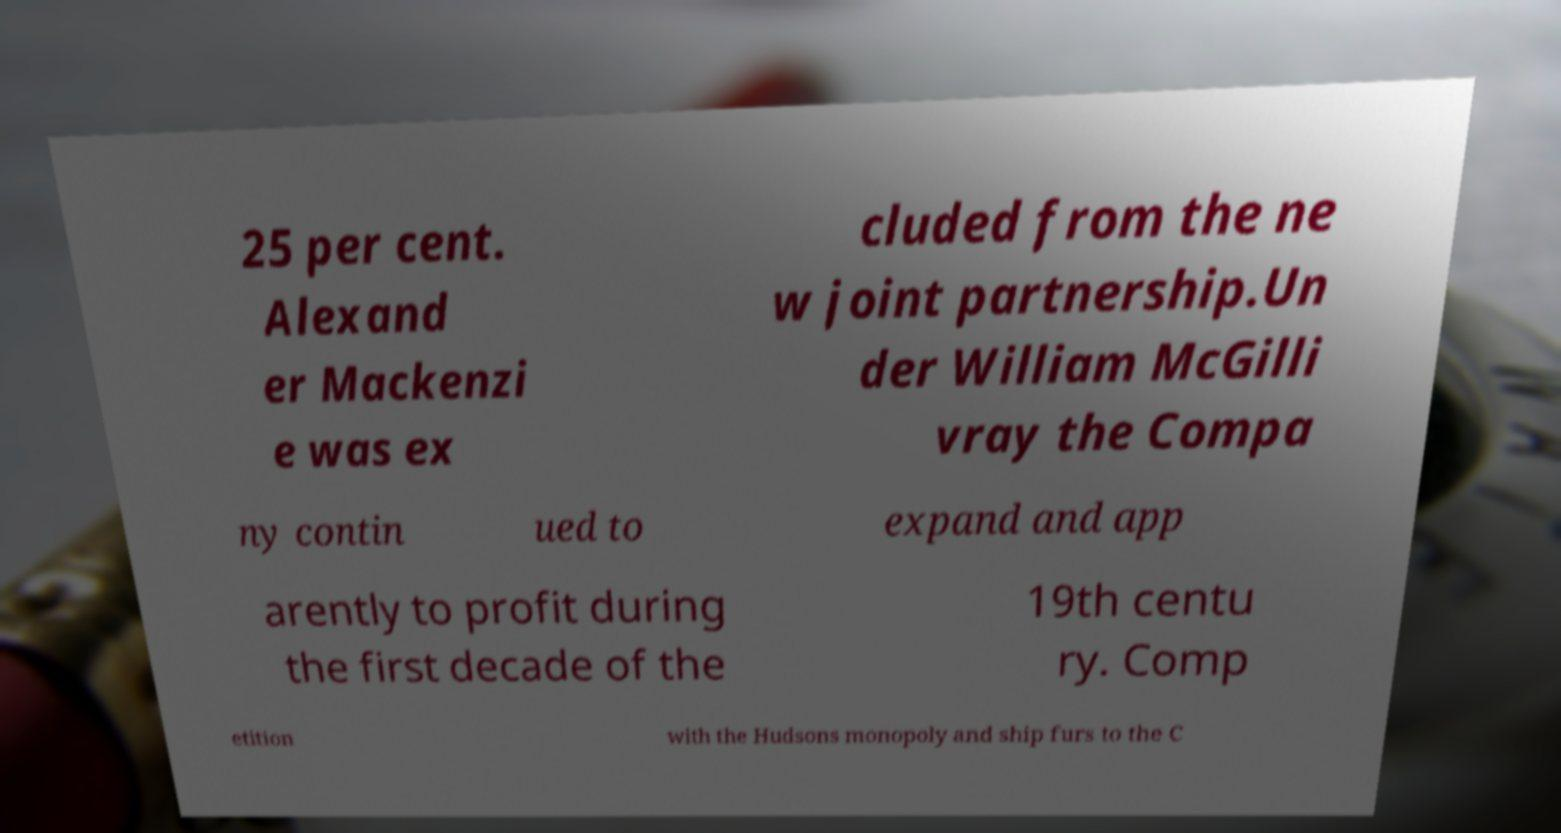Could you assist in decoding the text presented in this image and type it out clearly? 25 per cent. Alexand er Mackenzi e was ex cluded from the ne w joint partnership.Un der William McGilli vray the Compa ny contin ued to expand and app arently to profit during the first decade of the 19th centu ry. Comp etition with the Hudsons monopoly and ship furs to the C 